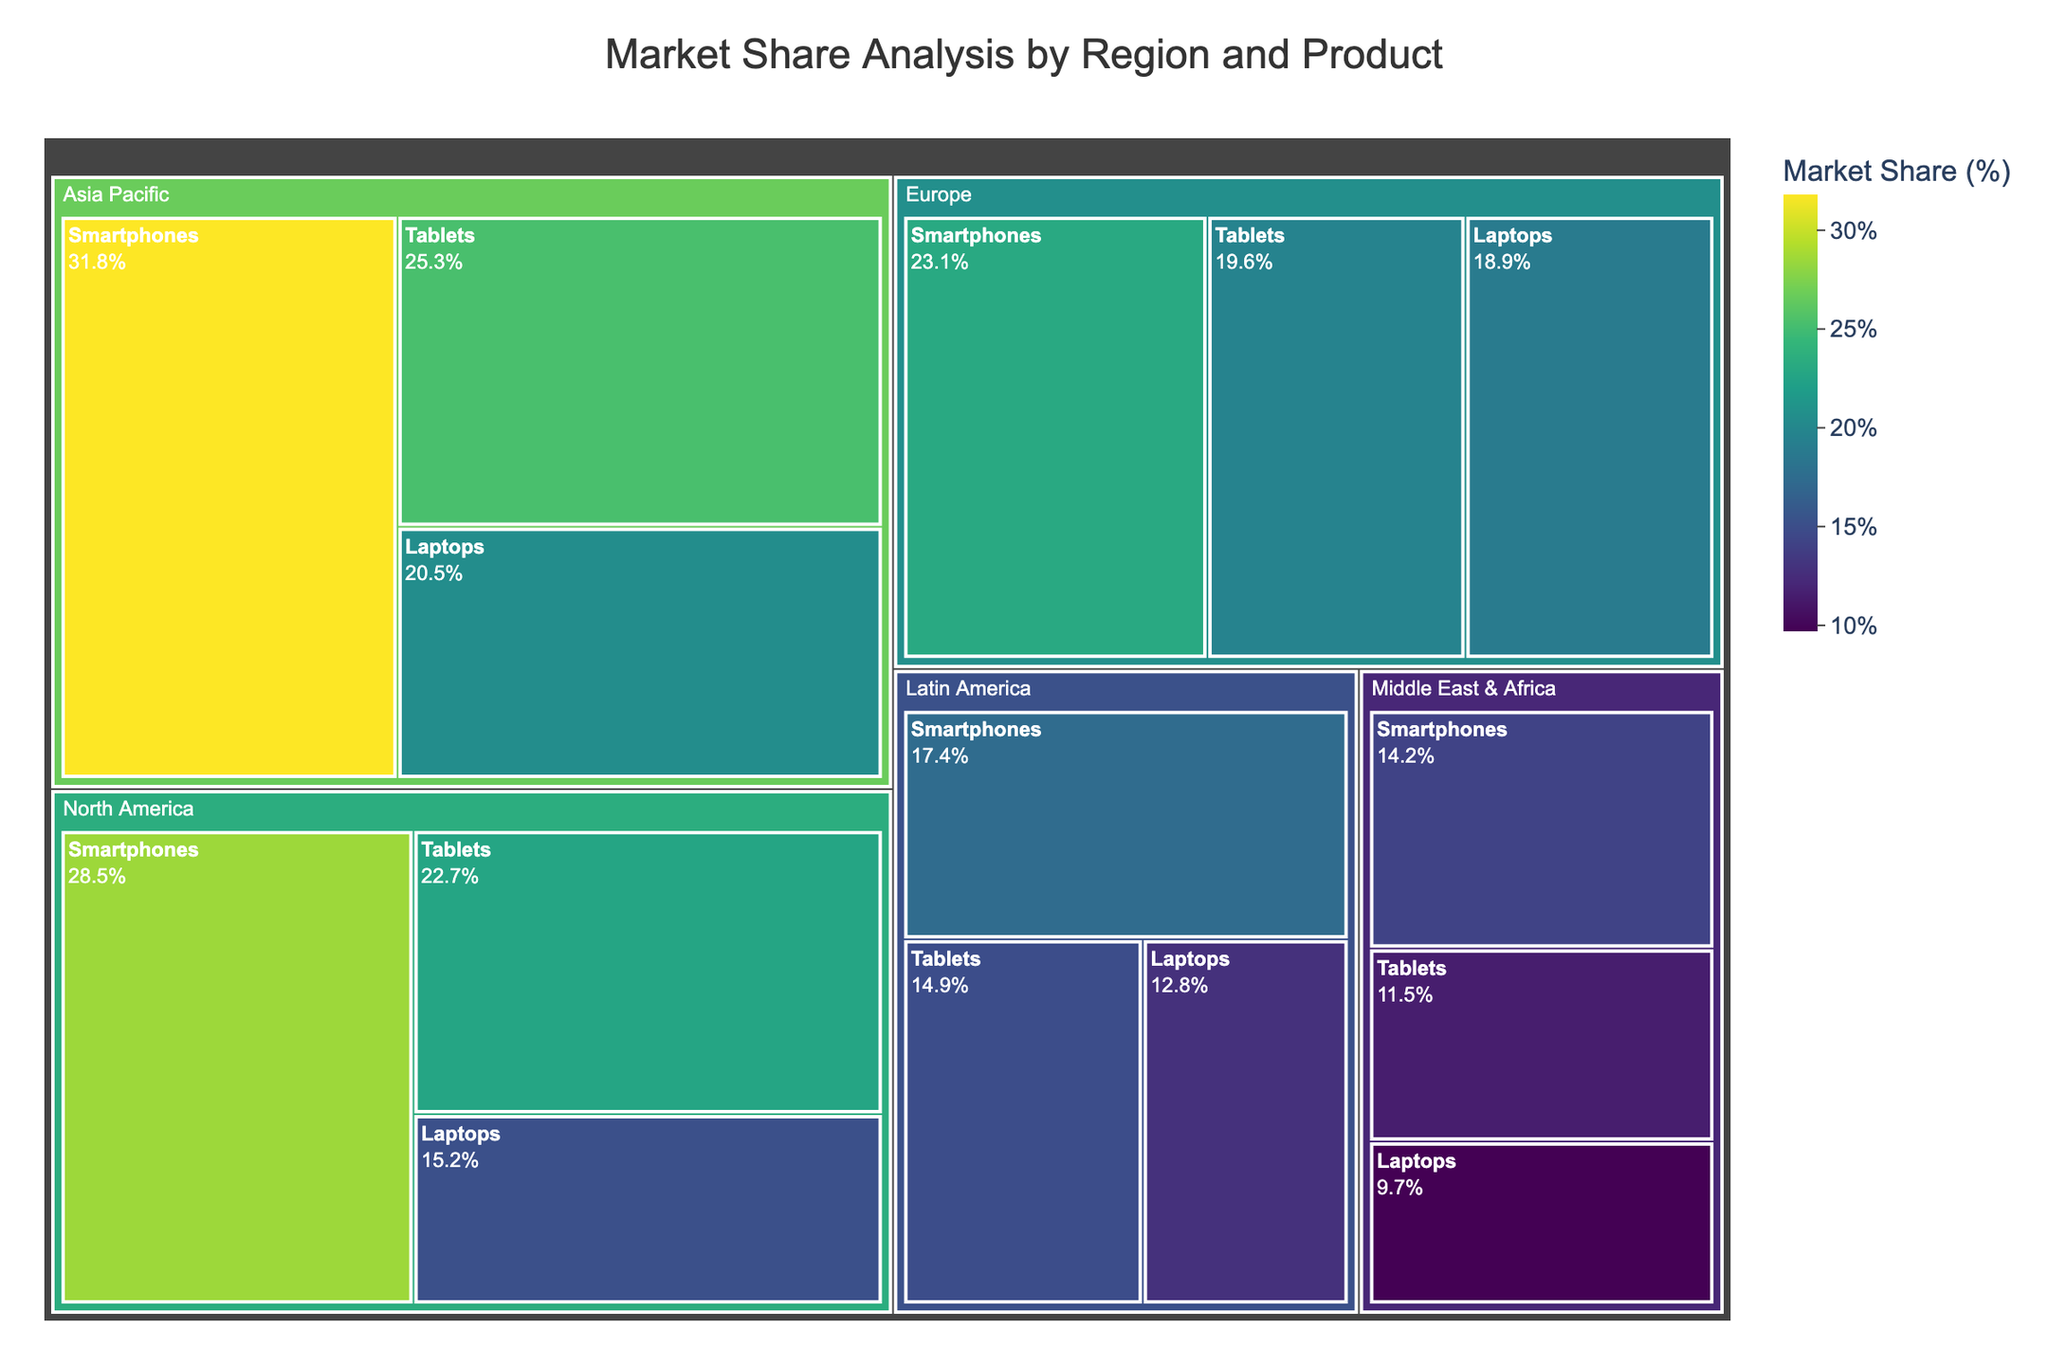What's the title of the figure? The title is usually located at the top of the figure. In this case, it indicates the content and focus of the plot. The title "Market Share Analysis by Region and Product" suggests that the figure shows market share data segmented by both region and product type.
Answer: Market Share Analysis by Region and Product Which region has the highest market share in Smartphones? To find this, look for the largest segment within each region categorized under "Smartphones". From the colors representing market share percentages, Asia Pacific shows the largest segment for Smartphones.
Answer: Asia Pacific Rank the regions in descending order of total market share for Tablets. Identify the segments labeled "Tablets" in each region and sort them by their market share values. Asia Pacific has 25.3%, North America has 22.7%, Europe has 19.6%, Latin America has 14.9%, and Middle East & Africa has 11.5%. Ordering these from highest to lowest gives: Asia Pacific, North America, Europe, Latin America, Middle East & Africa.
Answer: Asia Pacific, North America, Europe, Latin America, Middle East & Africa What is the sum of the market shares for Laptops in Europe and North America? Locate the market share values for the "Laptops" segments in both Europe and North America. Europe has 18.9%, and North America has 15.2%. Adding these values together gives 18.9% + 15.2% = 34.1%.
Answer: 34.1% Which product has the smallest market share in Latin America? Look at the segments in Latin America and identify the ones corresponding to various products. Find the one with the smallest percentage. Laptops have a 12.8% market share, Tablets 14.9%, and Smartphones 17.4%. The smallest value is for Laptops.
Answer: Laptops How does the market share for Tablets in North America compare to that in Europe? Compare the percentages representing "Tablets" in North America and Europe. North America has 22.7%, and Europe has 19.6%. Thus, Tablets in North America have a higher market share than in Europe.
Answer: Higher in North America What is the average market share of Laptops across all regions? Sum up the market shares for "Laptops" in all regions: North America (15.2%), Europe (18.9%), Asia Pacific (20.5%), Latin America (12.8%), and Middle East & Africa (9.7%). The total is 77.1%. The average is 77.1% divided by 5 regions, which equals 15.42%.
Answer: 15.42% What is the difference between the market share of Smartphones in Asia Pacific and Middle East & Africa? Subtract the market share of "Smartphones" in Middle East & Africa (14.2%) from that in Asia Pacific (31.8%). The calculation is 31.8% - 14.2% = 17.6%.
Answer: 17.6% Which product has the highest market share in the Middle East & Africa? Locate the segments representing various products within Middle East & Africa. The segment with the largest market share percentage is "Smartphones" at 14.2%.
Answer: Smartphones 